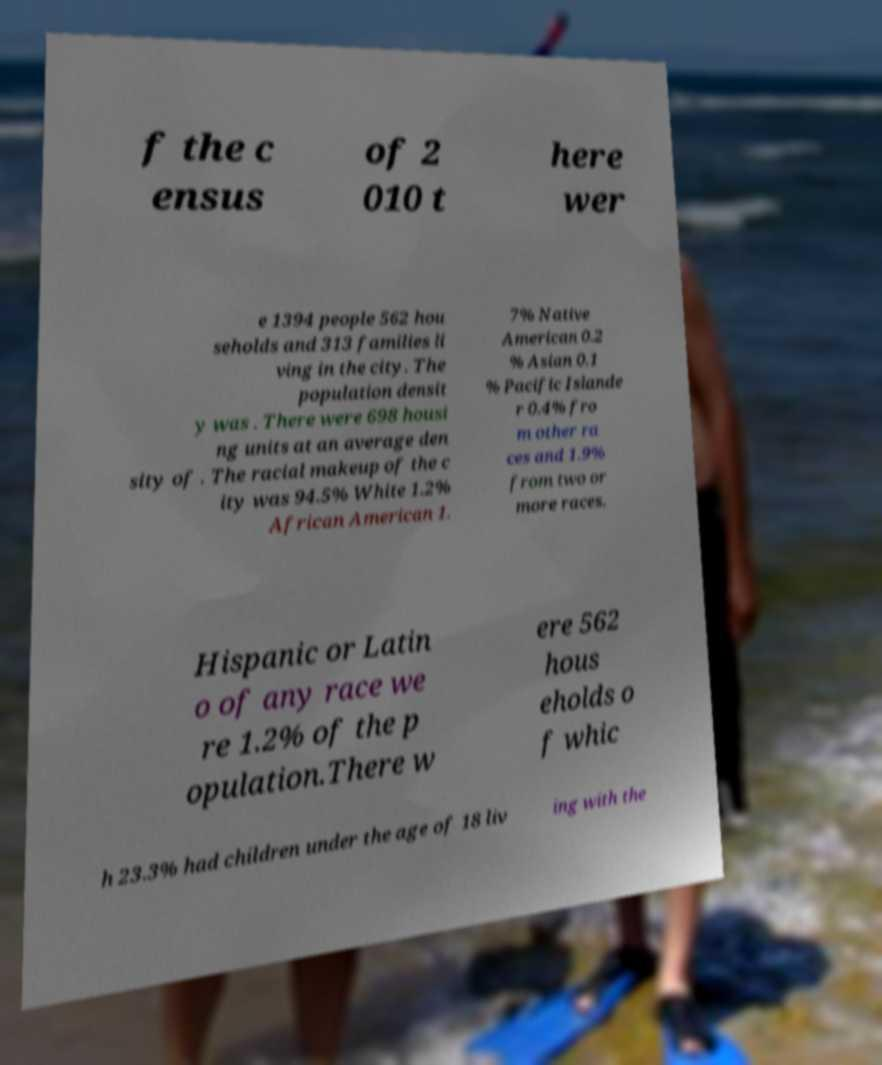I need the written content from this picture converted into text. Can you do that? f the c ensus of 2 010 t here wer e 1394 people 562 hou seholds and 313 families li ving in the city. The population densit y was . There were 698 housi ng units at an average den sity of . The racial makeup of the c ity was 94.5% White 1.2% African American 1. 7% Native American 0.2 % Asian 0.1 % Pacific Islande r 0.4% fro m other ra ces and 1.9% from two or more races. Hispanic or Latin o of any race we re 1.2% of the p opulation.There w ere 562 hous eholds o f whic h 23.3% had children under the age of 18 liv ing with the 